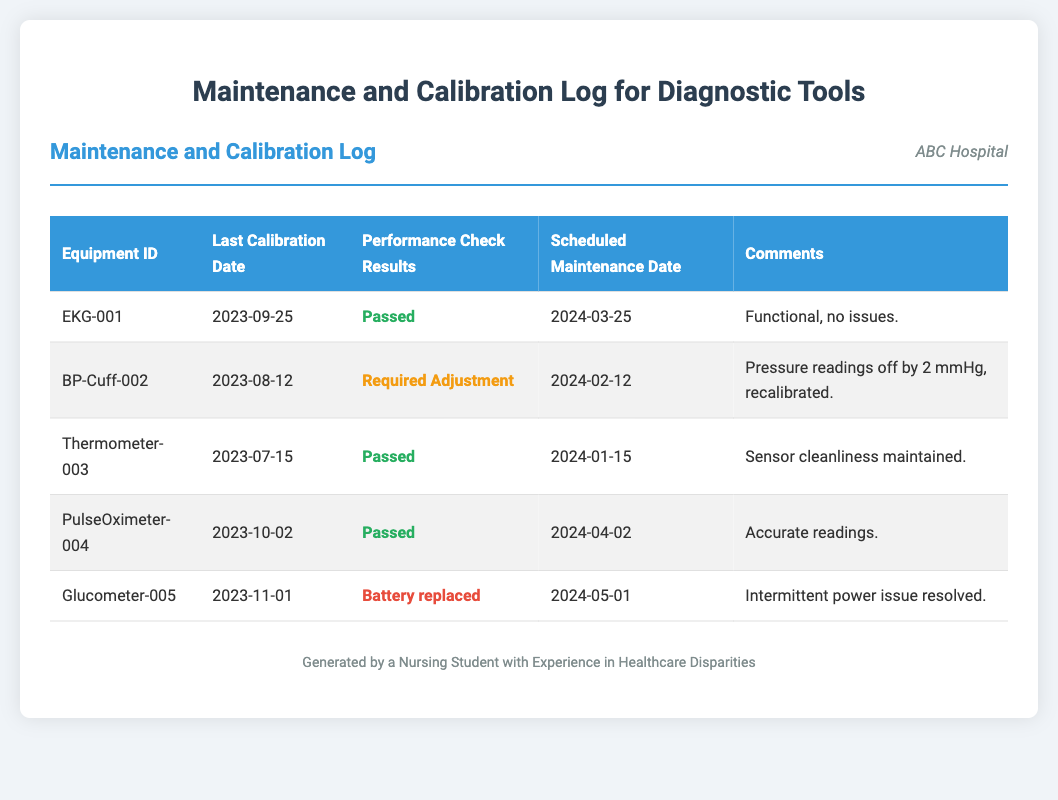What is the Equipment ID for the EKG? The Equipment ID is found in the first column of the table where EKG information is provided.
Answer: EKG-001 When was the last calibration date for the BP-Cuff? This date is found in the second column corresponding to the BP-Cuff equipment.
Answer: 2023-08-12 What are the performance check results for the Thermometer? The performance check results can be identified in the third column of the Thermometer entry.
Answer: Passed What is the scheduled maintenance date for the Pulse Oximeter? The scheduled maintenance date is listed in the fourth column for the Pulse Oximeter entry.
Answer: 2024-04-02 What comment is associated with the Glucometer? The comments can be found in the last column under the Glucometer entry.
Answer: Intermittent power issue resolved Which equipment required an adjustment during the last performance check? The performance check results indicate if any adjustments were needed, which is found in the third column.
Answer: BP-Cuff-002 How many total pieces of equipment are logged in this document? The total number of rows in the body of the table indicates the number of logged equipment.
Answer: 5 What is the color coding for passed performance checks? The color coding is indicated through the text color associated with specific results in the table.
Answer: Green Which equipment had a battery replaced as part of its maintenance? The last column indicates comments about battery maintenance in the Glucometer entry.
Answer: Glucometer-005 